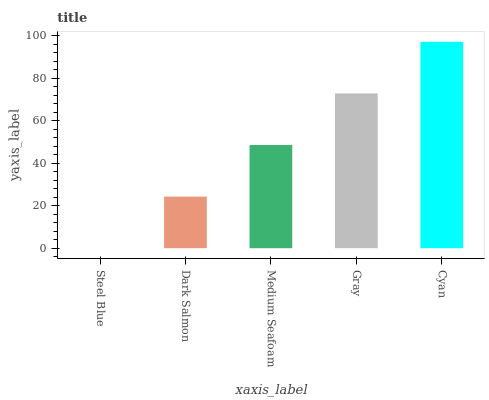Is Steel Blue the minimum?
Answer yes or no. Yes. Is Cyan the maximum?
Answer yes or no. Yes. Is Dark Salmon the minimum?
Answer yes or no. No. Is Dark Salmon the maximum?
Answer yes or no. No. Is Dark Salmon greater than Steel Blue?
Answer yes or no. Yes. Is Steel Blue less than Dark Salmon?
Answer yes or no. Yes. Is Steel Blue greater than Dark Salmon?
Answer yes or no. No. Is Dark Salmon less than Steel Blue?
Answer yes or no. No. Is Medium Seafoam the high median?
Answer yes or no. Yes. Is Medium Seafoam the low median?
Answer yes or no. Yes. Is Cyan the high median?
Answer yes or no. No. Is Steel Blue the low median?
Answer yes or no. No. 